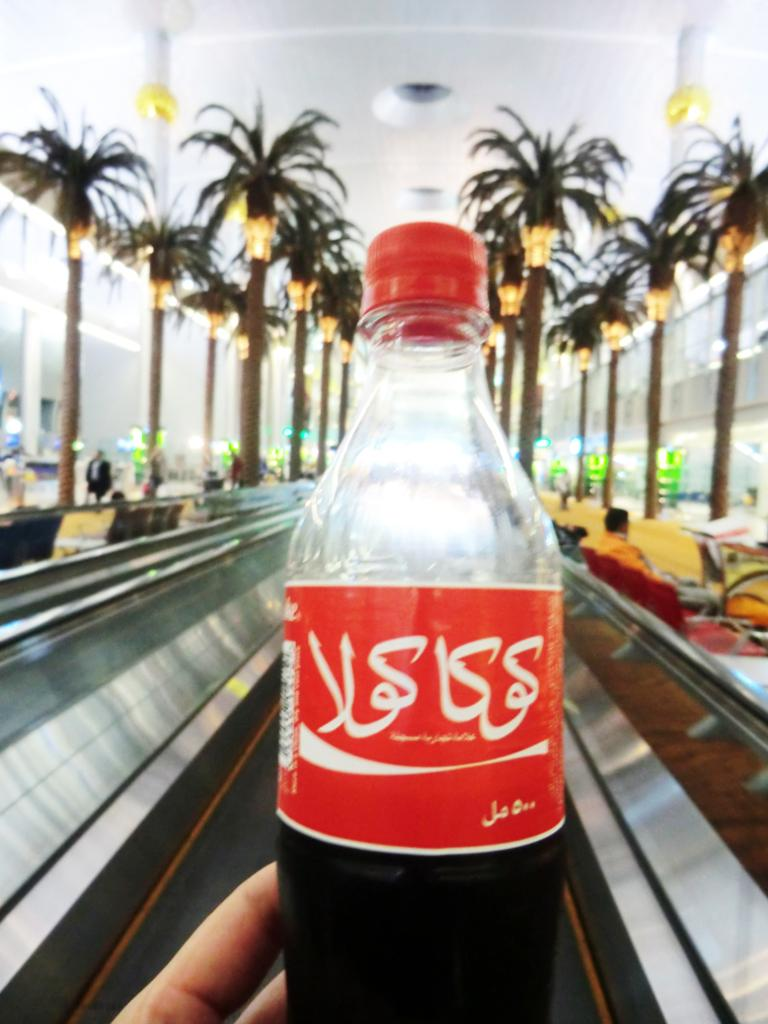What object is being held by a person in the image? There is a bottle in the image, and a person is holding it. What can be seen in the background of the image? There are trees, a wall, and light visible in the background. Can you describe the setting of the image? The image appears to be outdoors, given the presence of trees and light in the background. What type of fuel is being used by the person in the image? There is no indication in the image that the person is using any type of fuel. 